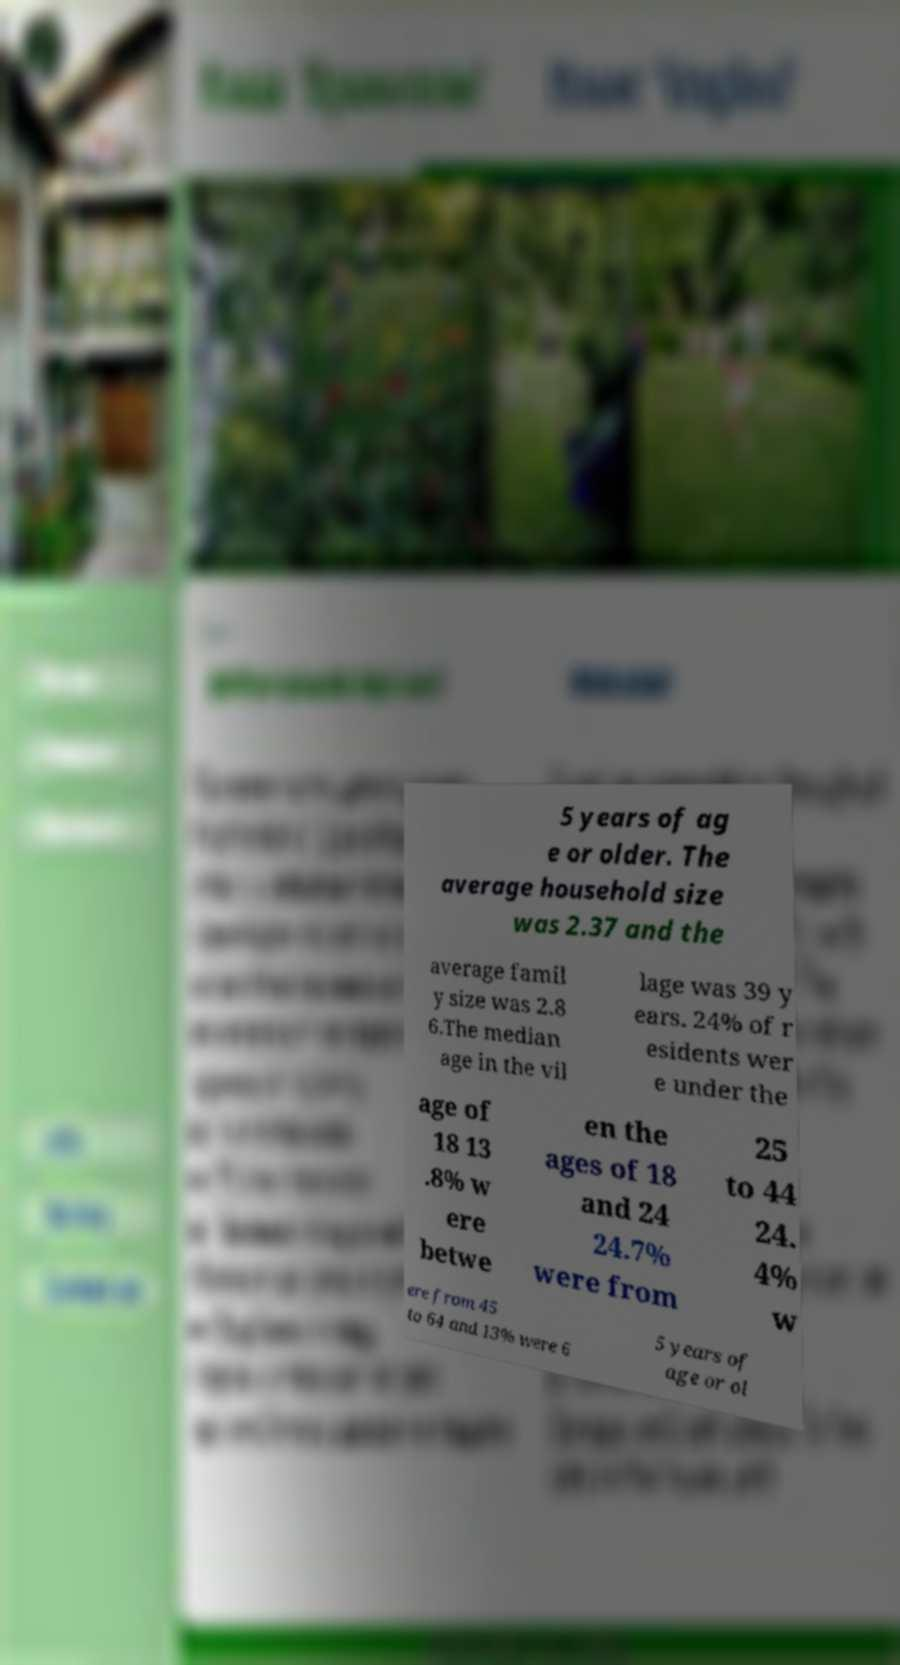Can you read and provide the text displayed in the image?This photo seems to have some interesting text. Can you extract and type it out for me? 5 years of ag e or older. The average household size was 2.37 and the average famil y size was 2.8 6.The median age in the vil lage was 39 y ears. 24% of r esidents wer e under the age of 18 13 .8% w ere betwe en the ages of 18 and 24 24.7% were from 25 to 44 24. 4% w ere from 45 to 64 and 13% were 6 5 years of age or ol 